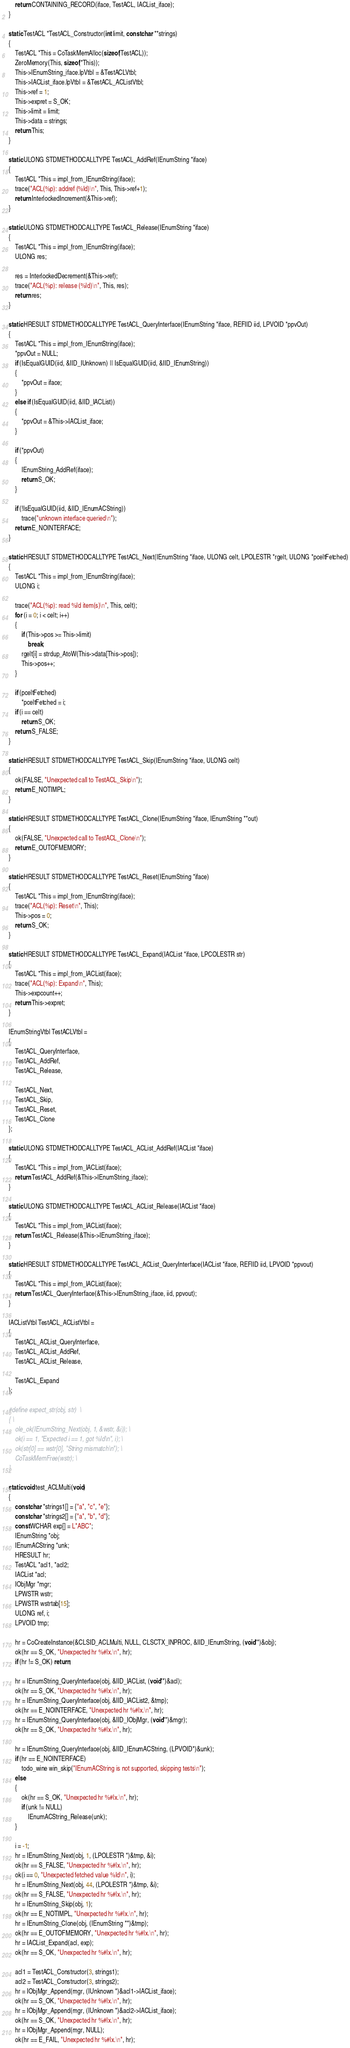<code> <loc_0><loc_0><loc_500><loc_500><_C_>    return CONTAINING_RECORD(iface, TestACL, IACList_iface);
}

static TestACL *TestACL_Constructor(int limit, const char **strings)
{
    TestACL *This = CoTaskMemAlloc(sizeof(TestACL));
    ZeroMemory(This, sizeof(*This));
    This->IEnumString_iface.lpVtbl = &TestACLVtbl;
    This->IACList_iface.lpVtbl = &TestACL_ACListVtbl;
    This->ref = 1;
    This->expret = S_OK;
    This->limit = limit;
    This->data = strings;
    return This;
}

static ULONG STDMETHODCALLTYPE TestACL_AddRef(IEnumString *iface)
{
    TestACL *This = impl_from_IEnumString(iface);
    trace("ACL(%p): addref (%ld)\n", This, This->ref+1);
    return InterlockedIncrement(&This->ref);
}

static ULONG STDMETHODCALLTYPE TestACL_Release(IEnumString *iface)
{
    TestACL *This = impl_from_IEnumString(iface);
    ULONG res;

    res = InterlockedDecrement(&This->ref);
    trace("ACL(%p): release (%ld)\n", This, res);
    return res;
}

static HRESULT STDMETHODCALLTYPE TestACL_QueryInterface(IEnumString *iface, REFIID iid, LPVOID *ppvOut)
{
    TestACL *This = impl_from_IEnumString(iface);
    *ppvOut = NULL;
    if (IsEqualGUID(iid, &IID_IUnknown) || IsEqualGUID(iid, &IID_IEnumString))
    {
        *ppvOut = iface;
    }
    else if (IsEqualGUID(iid, &IID_IACList))
    {
        *ppvOut = &This->IACList_iface;
    }

    if (*ppvOut)
    {
        IEnumString_AddRef(iface);
        return S_OK;
    }

    if (!IsEqualGUID(iid, &IID_IEnumACString))
        trace("unknown interface queried\n");
    return E_NOINTERFACE;
}

static HRESULT STDMETHODCALLTYPE TestACL_Next(IEnumString *iface, ULONG celt, LPOLESTR *rgelt, ULONG *pceltFetched)
{
    TestACL *This = impl_from_IEnumString(iface);
    ULONG i;

    trace("ACL(%p): read %ld item(s)\n", This, celt);
    for (i = 0; i < celt; i++)
    {
        if (This->pos >= This->limit)
            break;
        rgelt[i] = strdup_AtoW(This->data[This->pos]);
        This->pos++;
    }

    if (pceltFetched)
        *pceltFetched = i;
    if (i == celt)
        return S_OK;
    return S_FALSE;
}

static HRESULT STDMETHODCALLTYPE TestACL_Skip(IEnumString *iface, ULONG celt)
{
    ok(FALSE, "Unexpected call to TestACL_Skip\n");
    return E_NOTIMPL;
}

static HRESULT STDMETHODCALLTYPE TestACL_Clone(IEnumString *iface, IEnumString **out)
{
    ok(FALSE, "Unexpected call to TestACL_Clone\n");
    return E_OUTOFMEMORY;
}

static HRESULT STDMETHODCALLTYPE TestACL_Reset(IEnumString *iface)
{
    TestACL *This = impl_from_IEnumString(iface);
    trace("ACL(%p): Reset\n", This);
    This->pos = 0;
    return S_OK;
}

static HRESULT STDMETHODCALLTYPE TestACL_Expand(IACList *iface, LPCOLESTR str)
{
    TestACL *This = impl_from_IACList(iface);
    trace("ACL(%p): Expand\n", This);
    This->expcount++;
    return This->expret;
}

IEnumStringVtbl TestACLVtbl =
{
    TestACL_QueryInterface,
    TestACL_AddRef,
    TestACL_Release,

    TestACL_Next,
    TestACL_Skip,
    TestACL_Reset,
    TestACL_Clone
};

static ULONG STDMETHODCALLTYPE TestACL_ACList_AddRef(IACList *iface)
{
    TestACL *This = impl_from_IACList(iface);
    return TestACL_AddRef(&This->IEnumString_iface);
}

static ULONG STDMETHODCALLTYPE TestACL_ACList_Release(IACList *iface)
{
    TestACL *This = impl_from_IACList(iface);
    return TestACL_Release(&This->IEnumString_iface);
}

static HRESULT STDMETHODCALLTYPE TestACL_ACList_QueryInterface(IACList *iface, REFIID iid, LPVOID *ppvout)
{
    TestACL *This = impl_from_IACList(iface);
    return TestACL_QueryInterface(&This->IEnumString_iface, iid, ppvout);
}

IACListVtbl TestACL_ACListVtbl =
{
    TestACL_ACList_QueryInterface,
    TestACL_ACList_AddRef,
    TestACL_ACList_Release,

    TestACL_Expand
};

#define expect_str(obj, str)  \
{ \
    ole_ok(IEnumString_Next(obj, 1, &wstr, &i)); \
    ok(i == 1, "Expected i == 1, got %ld\n", i); \
    ok(str[0] == wstr[0], "String mismatch\n"); \
    CoTaskMemFree(wstr); \
}

static void test_ACLMulti(void)
{
    const char *strings1[] = {"a", "c", "e"};
    const char *strings2[] = {"a", "b", "d"};
    const WCHAR exp[] = L"ABC";
    IEnumString *obj;
    IEnumACString *unk;
    HRESULT hr;
    TestACL *acl1, *acl2;
    IACList *acl;
    IObjMgr *mgr;
    LPWSTR wstr;
    LPWSTR wstrtab[15];
    ULONG ref, i;
    LPVOID tmp;

    hr = CoCreateInstance(&CLSID_ACLMulti, NULL, CLSCTX_INPROC, &IID_IEnumString, (void**)&obj);
    ok(hr == S_OK, "Unexpected hr %#lx.\n", hr);
    if (hr != S_OK) return;

    hr = IEnumString_QueryInterface(obj, &IID_IACList, (void**)&acl);
    ok(hr == S_OK, "Unexpected hr %#lx.\n", hr);
    hr = IEnumString_QueryInterface(obj, &IID_IACList2, &tmp);
    ok(hr == E_NOINTERFACE, "Unexpected hr %#lx.\n", hr);
    hr = IEnumString_QueryInterface(obj, &IID_IObjMgr, (void**)&mgr);
    ok(hr == S_OK, "Unexpected hr %#lx.\n", hr);

    hr = IEnumString_QueryInterface(obj, &IID_IEnumACString, (LPVOID*)&unk);
    if (hr == E_NOINTERFACE)
        todo_wine win_skip("IEnumACString is not supported, skipping tests\n");
    else
    {
        ok(hr == S_OK, "Unexpected hr %#lx.\n", hr);
        if (unk != NULL)
            IEnumACString_Release(unk);
    }

    i = -1;
    hr = IEnumString_Next(obj, 1, (LPOLESTR *)&tmp, &i);
    ok(hr == S_FALSE, "Unexpected hr %#lx.\n", hr);
    ok(i == 0, "Unexpected fetched value %ld\n", i);
    hr = IEnumString_Next(obj, 44, (LPOLESTR *)&tmp, &i);
    ok(hr == S_FALSE, "Unexpected hr %#lx.\n", hr);
    hr = IEnumString_Skip(obj, 1);
    ok(hr == E_NOTIMPL, "Unexpected hr %#lx.\n", hr);
    hr = IEnumString_Clone(obj, (IEnumString **)&tmp);
    ok(hr == E_OUTOFMEMORY, "Unexpected hr %#lx.\n", hr);
    hr = IACList_Expand(acl, exp);
    ok(hr == S_OK, "Unexpected hr %#lx.\n", hr);

    acl1 = TestACL_Constructor(3, strings1);
    acl2 = TestACL_Constructor(3, strings2);
    hr = IObjMgr_Append(mgr, (IUnknown *)&acl1->IACList_iface);
    ok(hr == S_OK, "Unexpected hr %#lx.\n", hr);
    hr = IObjMgr_Append(mgr, (IUnknown *)&acl2->IACList_iface);
    ok(hr == S_OK, "Unexpected hr %#lx.\n", hr);
    hr = IObjMgr_Append(mgr, NULL);
    ok(hr == E_FAIL, "Unexpected hr %#lx.\n", hr);</code> 